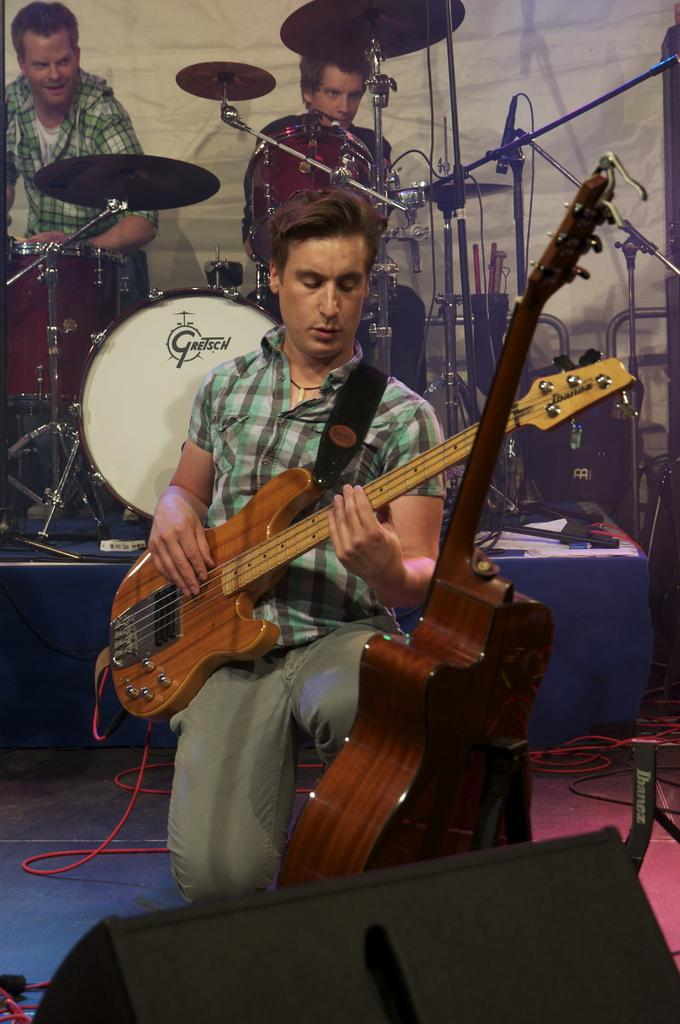How many people are in the image? There are three people in the image. What are the people in the image doing? The three people are playing musical instruments. What type of advertisement can be seen in the image? There is no advertisement present in the image. What sound can be heard coming from the can in the image? There is no can present in the image, and therefore no sound can be heard coming from it. 